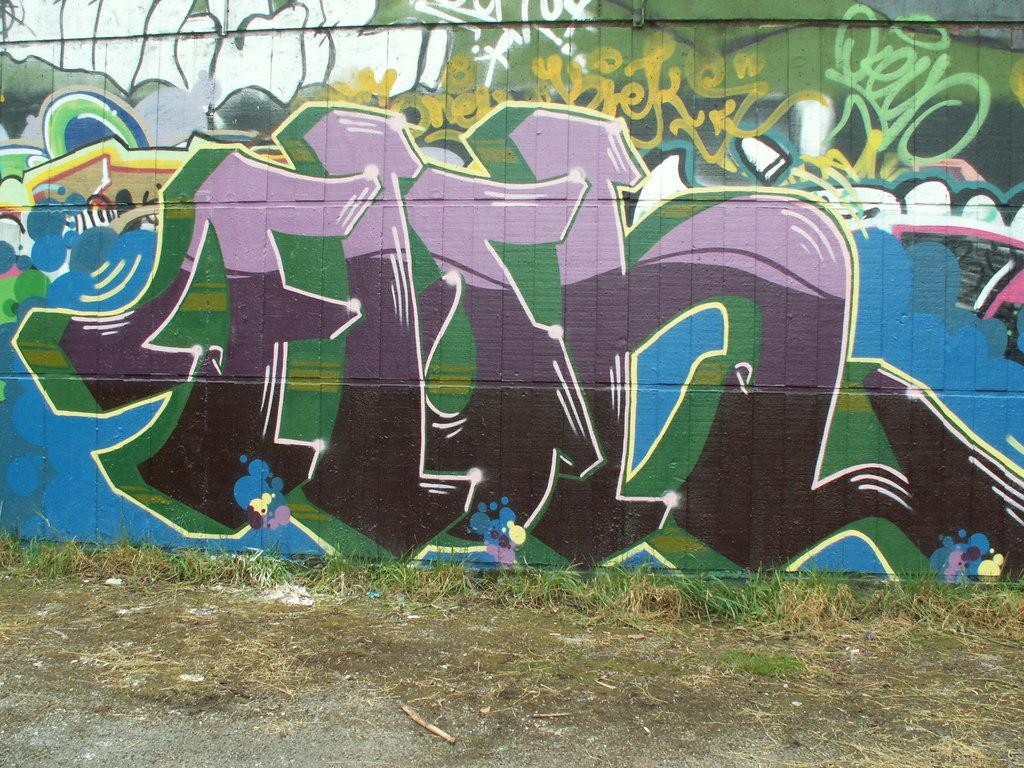What type of natural vegetation is present in the image? There is grass in the image. What objects can be seen on the ground in the image? There are sticks on the ground in the image. What type of artwork is visible on the wall in the image? There is a painting on the wall in the image. What type of receipt is visible on the painting in the image? There is no receipt present in the image, and the painting does not have any receipts on it. 